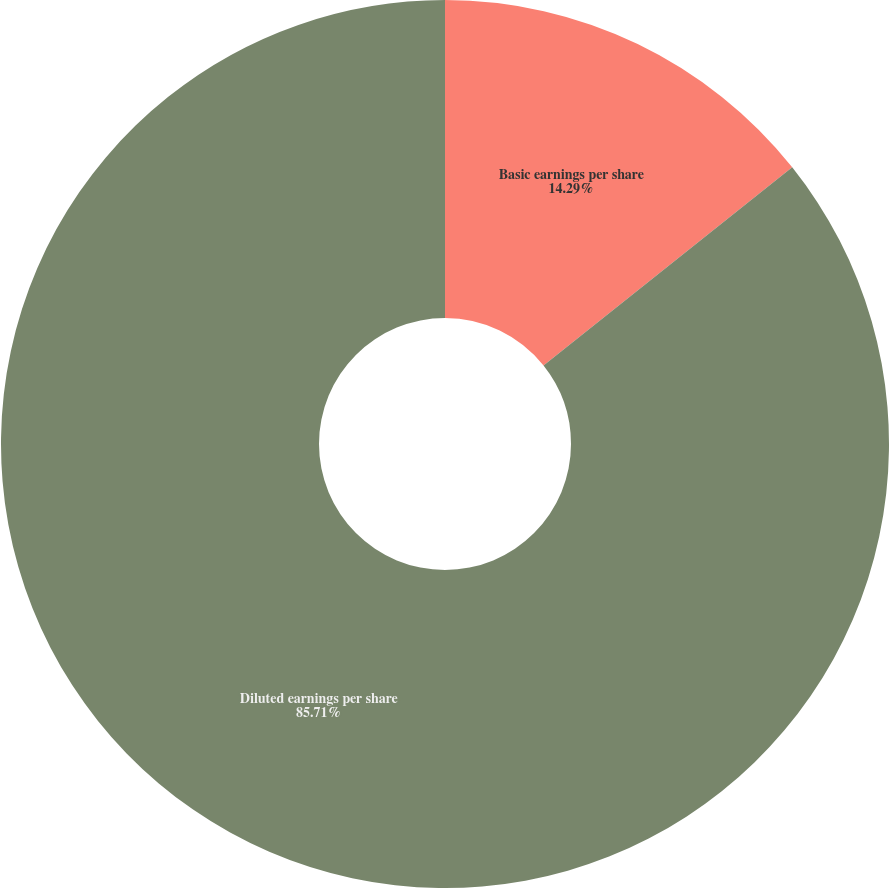<chart> <loc_0><loc_0><loc_500><loc_500><pie_chart><fcel>Basic earnings per share<fcel>Diluted earnings per share<nl><fcel>14.29%<fcel>85.71%<nl></chart> 